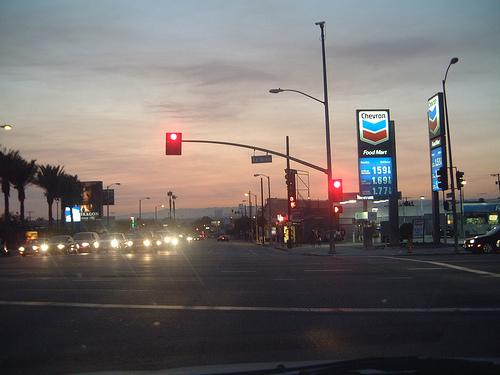What color is the traffic light?
Answer briefly. Red. What should oncoming traffic do?
Concise answer only. Stop. How much is the gas price?
Write a very short answer. 1.59. Can a person buy pizza at the gas station?
Keep it brief. No. 